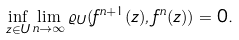Convert formula to latex. <formula><loc_0><loc_0><loc_500><loc_500>\inf _ { z \in U } \lim _ { n \to \infty } \varrho _ { U } ( f ^ { n + 1 } ( z ) , f ^ { n } ( z ) ) = 0 .</formula> 